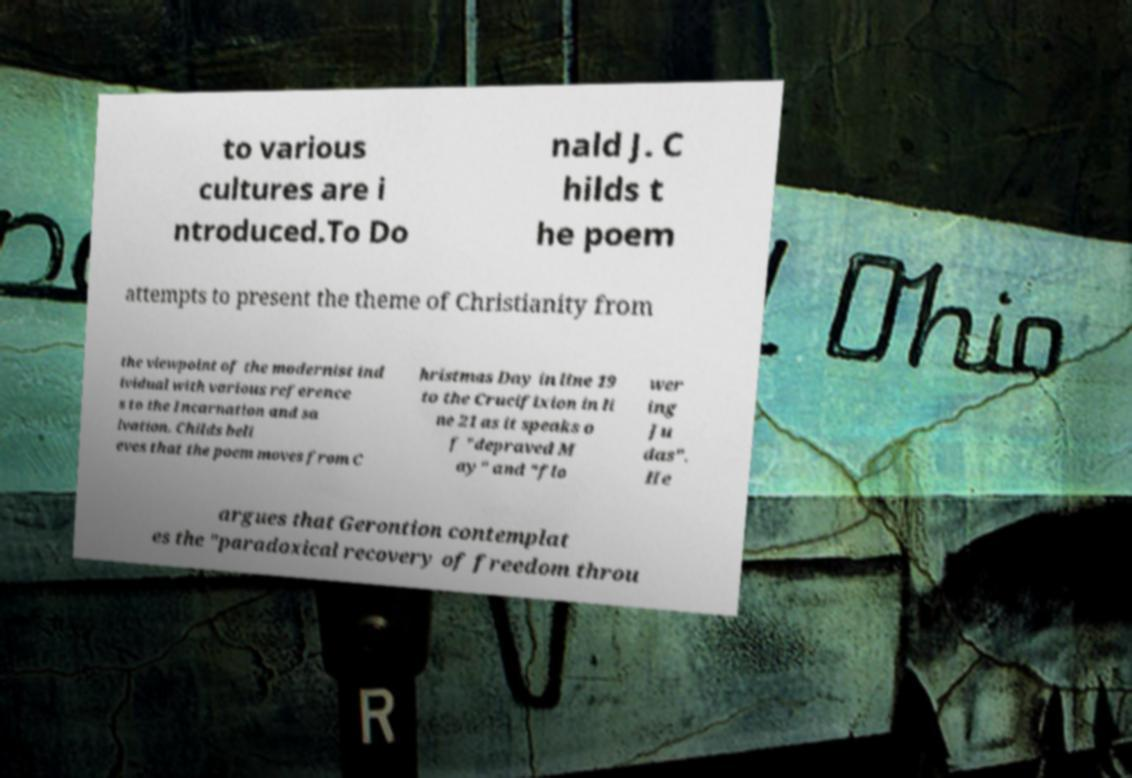Can you accurately transcribe the text from the provided image for me? to various cultures are i ntroduced.To Do nald J. C hilds t he poem attempts to present the theme of Christianity from the viewpoint of the modernist ind ividual with various reference s to the Incarnation and sa lvation. Childs beli eves that the poem moves from C hristmas Day in line 19 to the Crucifixion in li ne 21 as it speaks o f "depraved M ay" and "flo wer ing Ju das". He argues that Gerontion contemplat es the "paradoxical recovery of freedom throu 